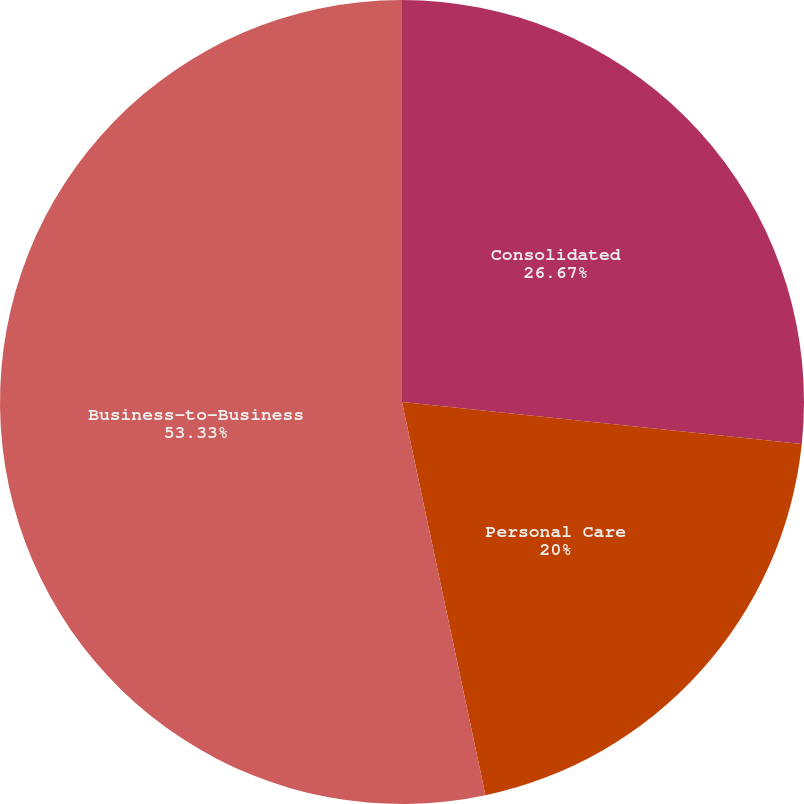<chart> <loc_0><loc_0><loc_500><loc_500><pie_chart><fcel>Consolidated<fcel>Personal Care<fcel>Business-to-Business<nl><fcel>26.67%<fcel>20.0%<fcel>53.33%<nl></chart> 